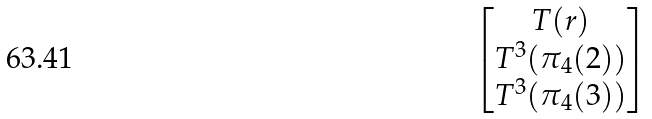<formula> <loc_0><loc_0><loc_500><loc_500>\begin{bmatrix} T ( r ) \\ T ^ { 3 } ( \pi _ { 4 } ( 2 ) ) \\ T ^ { 3 } ( \pi _ { 4 } ( 3 ) ) \end{bmatrix}</formula> 